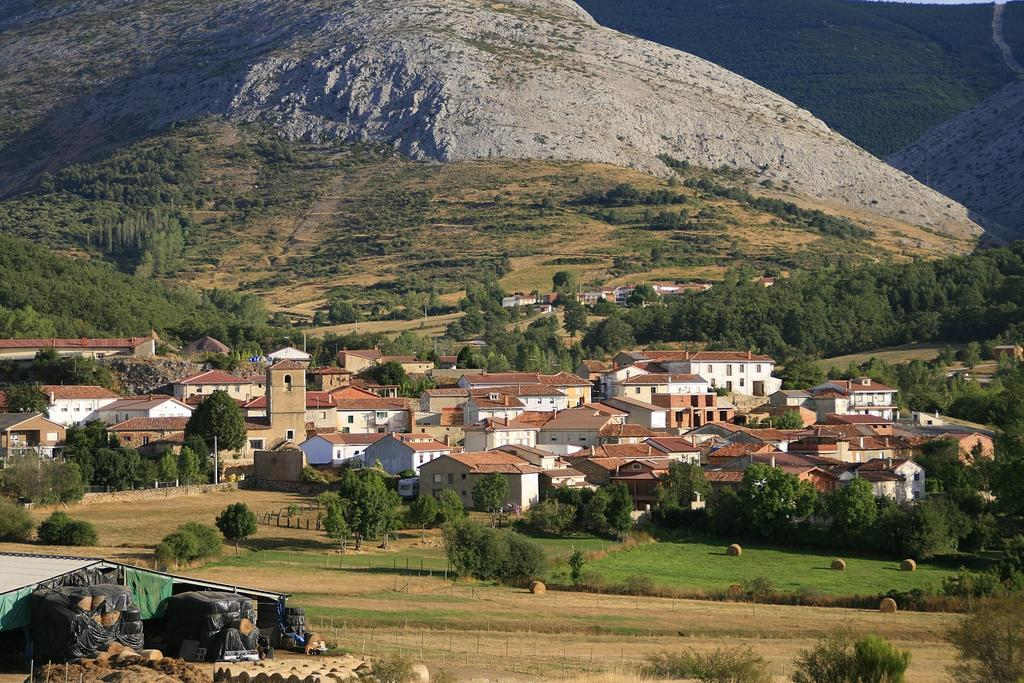What type of structures can be seen in the image? There are buildings in the image. What natural elements are present in the image? There are trees in the image. What man-made objects can be seen in the image? There are poles in the image. What other objects are visible in the image? There are other objects in the image. Where are the black color objects located in the image? The black color objects are on the left side of the image. What can be seen in the distance in the image? There are hills visible in the background of the image. Is there any coal visible in the image? There is no coal present in the image. What type of furniture can be seen in the image? There is no furniture present in the image. 